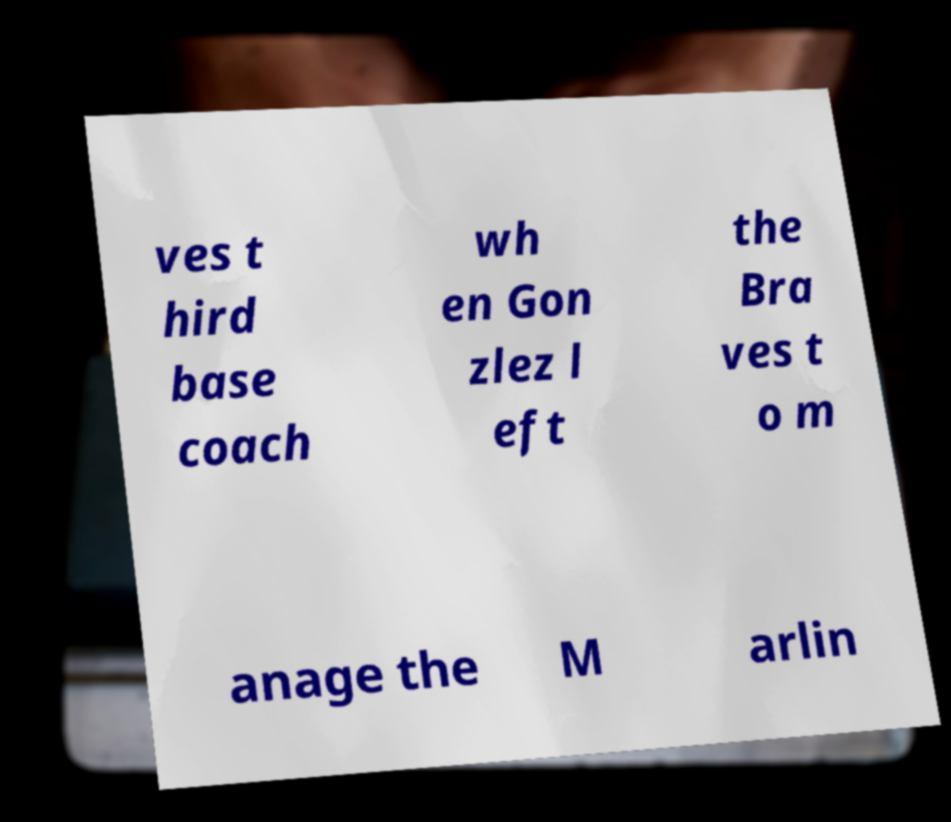Could you extract and type out the text from this image? ves t hird base coach wh en Gon zlez l eft the Bra ves t o m anage the M arlin 